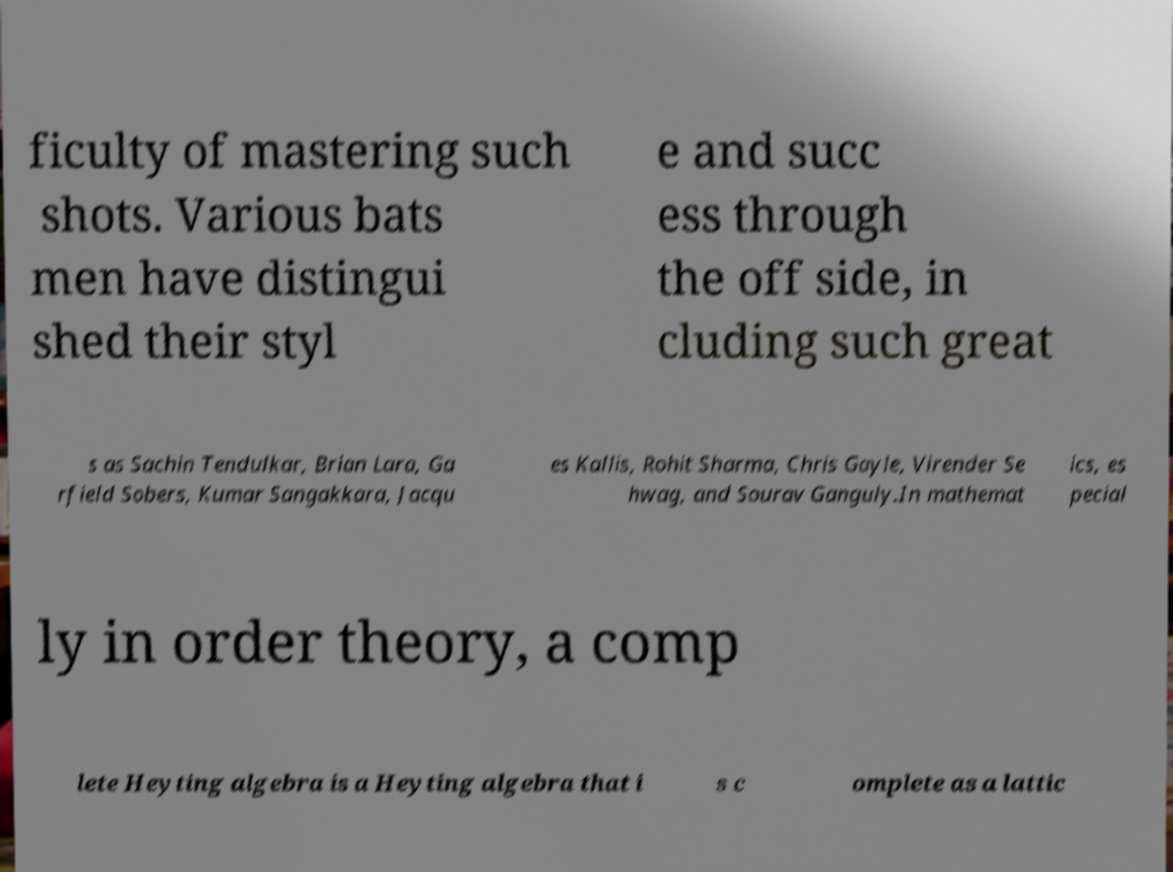Could you extract and type out the text from this image? ficulty of mastering such shots. Various bats men have distingui shed their styl e and succ ess through the off side, in cluding such great s as Sachin Tendulkar, Brian Lara, Ga rfield Sobers, Kumar Sangakkara, Jacqu es Kallis, Rohit Sharma, Chris Gayle, Virender Se hwag, and Sourav Ganguly.In mathemat ics, es pecial ly in order theory, a comp lete Heyting algebra is a Heyting algebra that i s c omplete as a lattic 